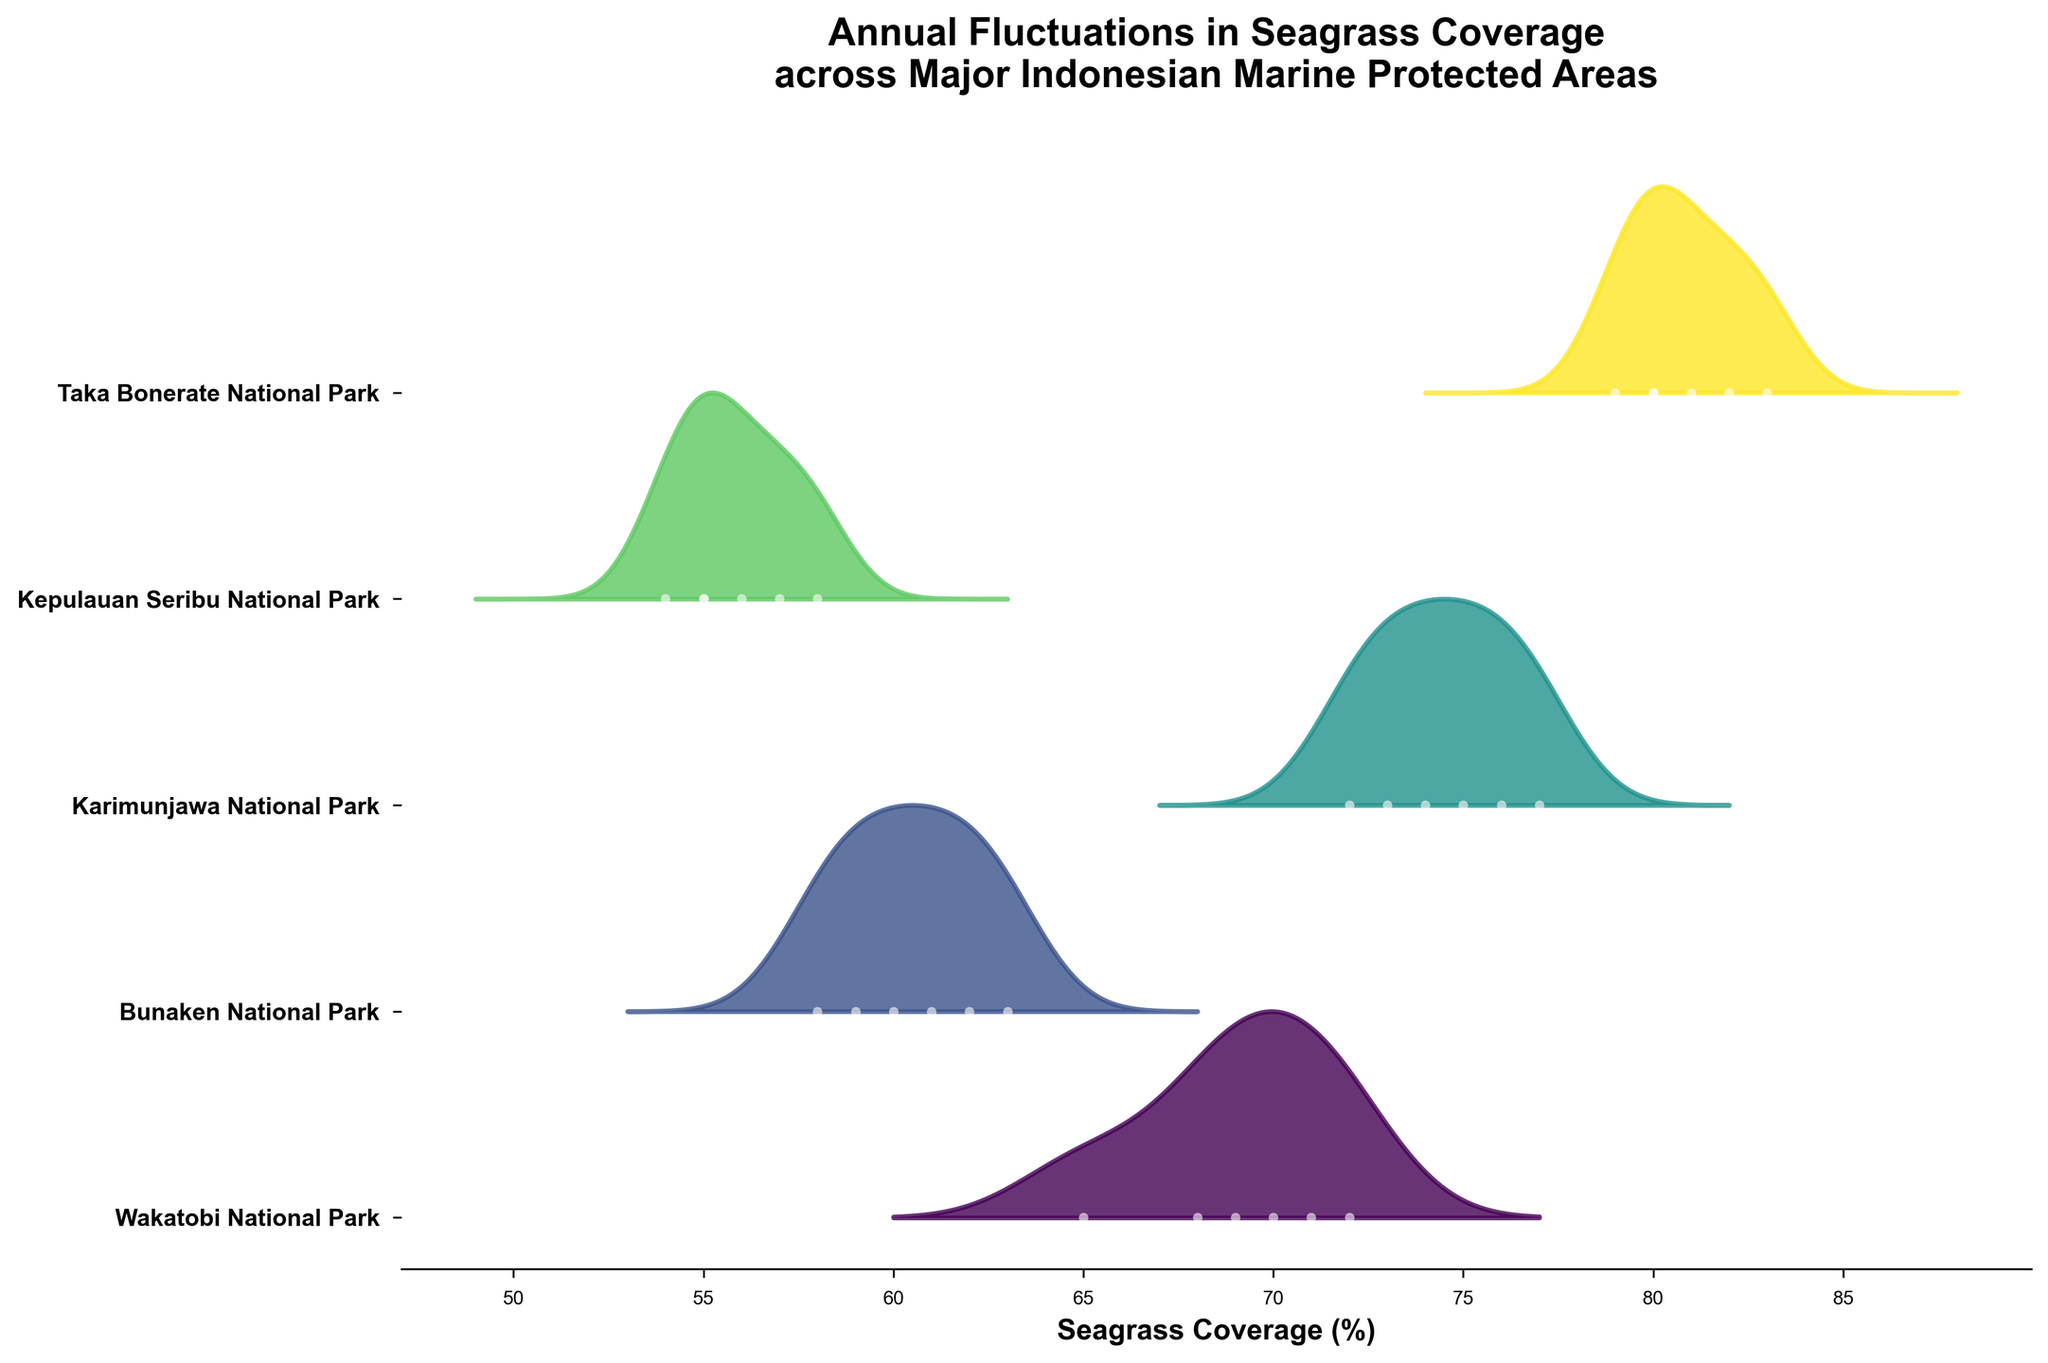What is the title of the figure? The title is located at the top of the figure, and it summarizes the main idea of the plot.
Answer: Annual Fluctuations in Seagrass Coverage across Major Indonesian Marine Protected Areas How many marine protected areas (MPAs) are displayed in the figure? The MPAs are listed on the y-axis, each with a corresponding ridgeline plot. You can count the number of unique labels on the y-axis.
Answer: 5 Which MPA has the highest average seagrass coverage based on the plot? By visually inspecting the plot, we can see the distribution of seagrass coverage for each MPA. Taka Bonerate National Park's distribution is higher on the x-axis compared to the others.
Answer: Taka Bonerate National Park What is the trend in seagrass coverage for Wakatobi National Park over the years? By looking at the plot for Wakatobi National Park, you can observe the dots representing coverage over the years. The trend is visible in the relative height of these points over time.
Answer: Increasing Compare the seagrass coverage trend between Bunaken National Park and Karimunjawa National Park. Which one shows a more consistent increase? Observing the plotted points for both MPAs, Karimunjawa National Park shows a more steady and consistent increase in coverage across the years than Bunaken National Park.
Answer: Karimunjawa National Park What is the lowest seagrass coverage observed in Kepulauan Seribu National Park? By looking at the series of points representing coverage for Kepulauan Seribu National Park, the lowest point can be identified easily.
Answer: 54% Identify the MPA with the most fluctuating seagrass coverage from 2015 to 2020. How do you determine this from the plot? The MPA with the most fluctuating coverage can be identified by the spread of the points and KDE ridgelines. Kepulauan Seribu National Park shows significant variation over time.
Answer: Kepulauan Seribu National Park Which MPA shows a decreasing trend in seagrass coverage towards the later years? By examining the series of points for each MPA, it appears that Wakatobi National Park exhibits a slight decrease in the latter years (2019, 2020).
Answer: Wakatobi National Park How does the range of coverage for Taka Bonerate National Park compare to the range for Karimunjawa National Park? Taka Bonerate National Park generally maintains coverage between 79% and 83%, while Karimunjawa National Park ranges from 72% to 77%. By examining the KDE and end points, this comparison is clear.
Answer: Taka Bonerate National Park has a narrower range Looking at the figure, which year had the highest seagrass coverage for all MPAs combined? By identifying the points on the far right across all MPAs, the year that appears most frequently at the maximum coverage point can be deduced, which stands out prominently for multiple parks.
Answer: 2020 